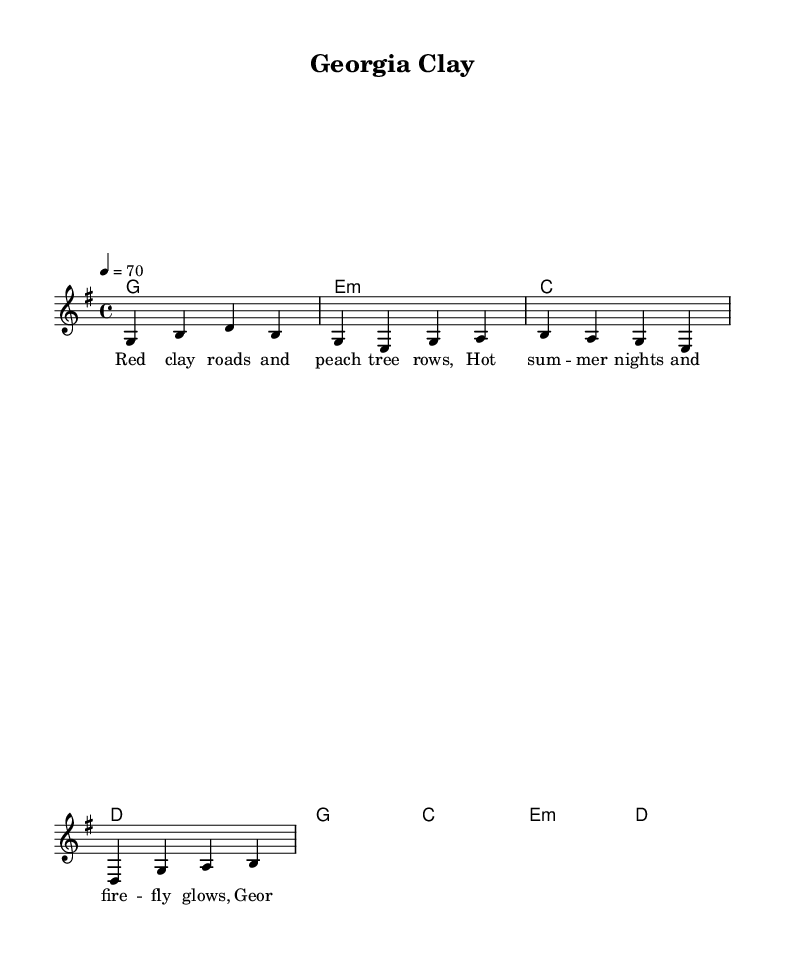What is the key signature of this music? The key signature indicated in the music is G major, which contains one sharp (F#), visible at the beginning of the staff.
Answer: G major What is the time signature of this music? The time signature shown in the music is 4/4, meaning there are four beats in each measure and the quarter note receives one beat.
Answer: 4/4 What is the tempo marking for this music? The tempo marking indicates a speed of 70 beats per minute, which is given in the code reads "4 = 70" referring to the quarter note.
Answer: 70 How many measures are there in the verse? The verse consists of four measures, as shown by the four chord progressions (each chord representing one measure).
Answer: 4 What chords are used in the chorus? The chords used in the chorus are G, C, E minor, and D, listed in the chord mode section of the music.
Answer: G, C, E minor, D What is the first line of the lyrics in the verse? The first line of the verse lyrics is "Red clay roads and peach tree rows," found in the associated lyric mode for the melody.
Answer: Red clay roads and peach tree rows How does the chorus express southern pride based on the lyrics? The chorus expresses southern pride through the line "Peach State pride, it never wanes," emphasizing a strong connection to Georgia and its culture.
Answer: Peach State pride, it never wanes 